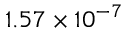Convert formula to latex. <formula><loc_0><loc_0><loc_500><loc_500>1 . 5 7 \times 1 0 ^ { - 7 }</formula> 